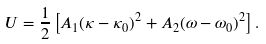<formula> <loc_0><loc_0><loc_500><loc_500>U = \frac { 1 } { 2 } \left [ A _ { 1 } ( \kappa - \kappa _ { 0 } ) ^ { 2 } + A _ { 2 } ( \omega - \omega _ { 0 } ) ^ { 2 } \right ] .</formula> 